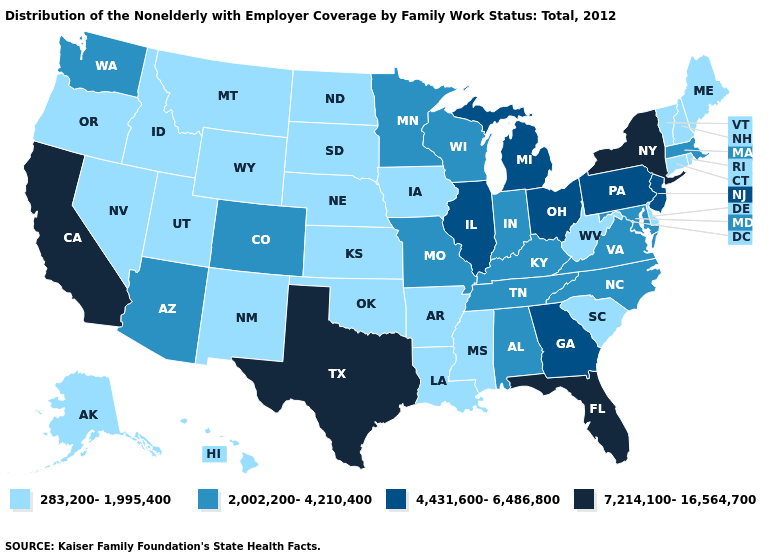What is the value of Maine?
Keep it brief. 283,200-1,995,400. What is the highest value in the MidWest ?
Give a very brief answer. 4,431,600-6,486,800. What is the value of Michigan?
Answer briefly. 4,431,600-6,486,800. Name the states that have a value in the range 7,214,100-16,564,700?
Be succinct. California, Florida, New York, Texas. Is the legend a continuous bar?
Be succinct. No. Does Georgia have a higher value than Connecticut?
Short answer required. Yes. Name the states that have a value in the range 283,200-1,995,400?
Concise answer only. Alaska, Arkansas, Connecticut, Delaware, Hawaii, Idaho, Iowa, Kansas, Louisiana, Maine, Mississippi, Montana, Nebraska, Nevada, New Hampshire, New Mexico, North Dakota, Oklahoma, Oregon, Rhode Island, South Carolina, South Dakota, Utah, Vermont, West Virginia, Wyoming. What is the value of Mississippi?
Answer briefly. 283,200-1,995,400. Which states have the lowest value in the West?
Answer briefly. Alaska, Hawaii, Idaho, Montana, Nevada, New Mexico, Oregon, Utah, Wyoming. Name the states that have a value in the range 7,214,100-16,564,700?
Give a very brief answer. California, Florida, New York, Texas. Does Florida have a lower value than California?
Concise answer only. No. What is the lowest value in the South?
Quick response, please. 283,200-1,995,400. Name the states that have a value in the range 2,002,200-4,210,400?
Short answer required. Alabama, Arizona, Colorado, Indiana, Kentucky, Maryland, Massachusetts, Minnesota, Missouri, North Carolina, Tennessee, Virginia, Washington, Wisconsin. Name the states that have a value in the range 2,002,200-4,210,400?
Answer briefly. Alabama, Arizona, Colorado, Indiana, Kentucky, Maryland, Massachusetts, Minnesota, Missouri, North Carolina, Tennessee, Virginia, Washington, Wisconsin. What is the value of Mississippi?
Short answer required. 283,200-1,995,400. 